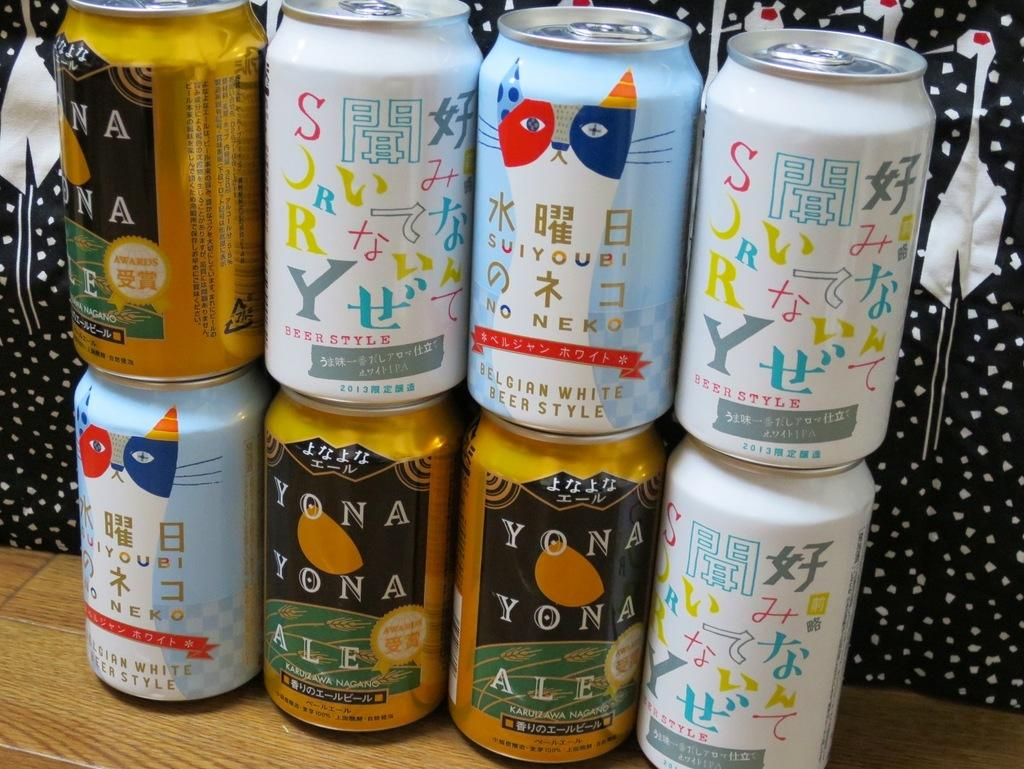<image>
Create a compact narrative representing the image presented. Several cans of Beer sit on a wooden table with three yellow cans by YONA YONA 